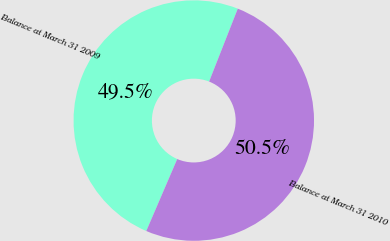Convert chart. <chart><loc_0><loc_0><loc_500><loc_500><pie_chart><fcel>Balance at March 31 2009<fcel>Balance at March 31 2010<nl><fcel>49.5%<fcel>50.5%<nl></chart> 